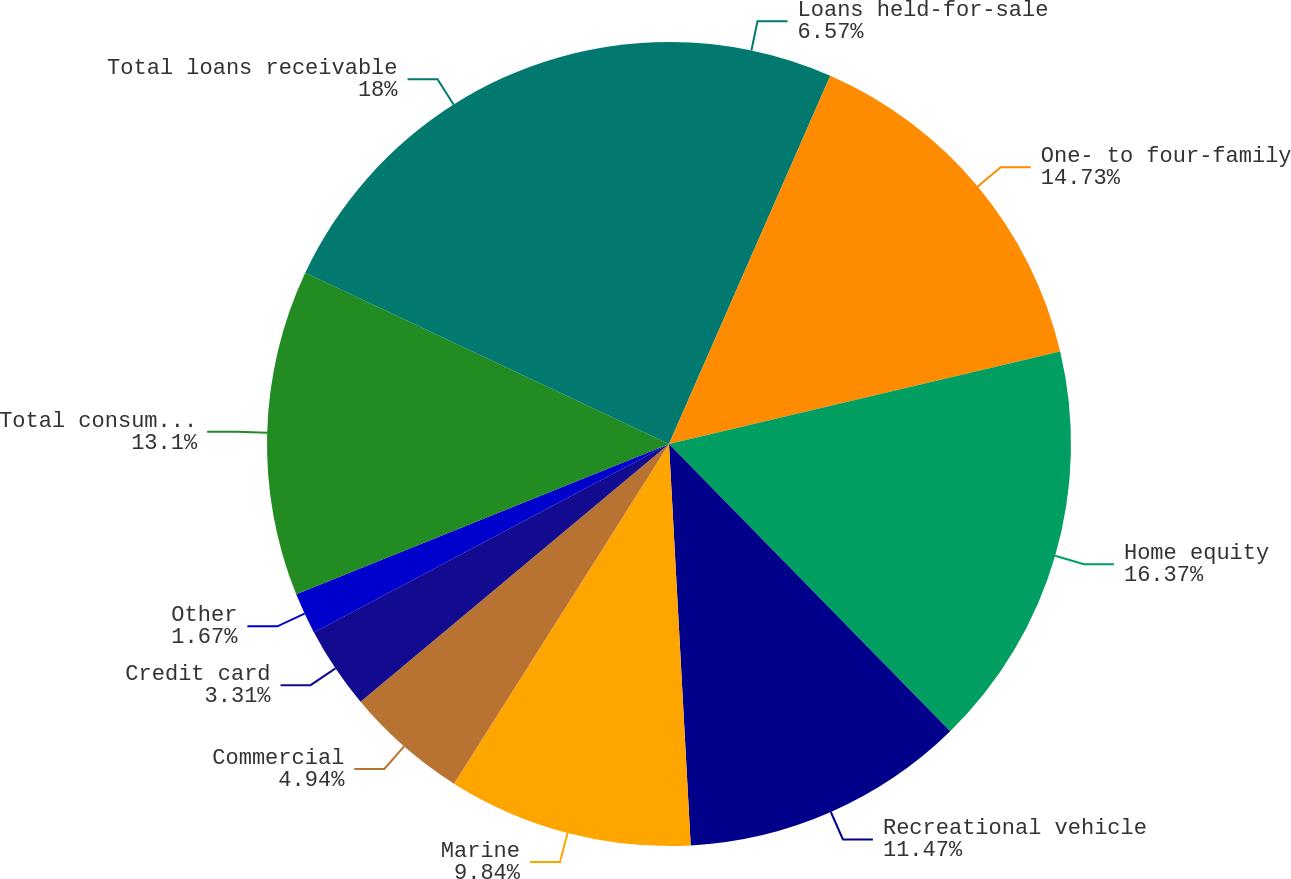Convert chart. <chart><loc_0><loc_0><loc_500><loc_500><pie_chart><fcel>Loans held-for-sale<fcel>One- to four-family<fcel>Home equity<fcel>Recreational vehicle<fcel>Marine<fcel>Commercial<fcel>Credit card<fcel>Other<fcel>Total consumer and other loans<fcel>Total loans receivable<nl><fcel>6.57%<fcel>14.73%<fcel>16.37%<fcel>11.47%<fcel>9.84%<fcel>4.94%<fcel>3.31%<fcel>1.67%<fcel>13.1%<fcel>18.0%<nl></chart> 